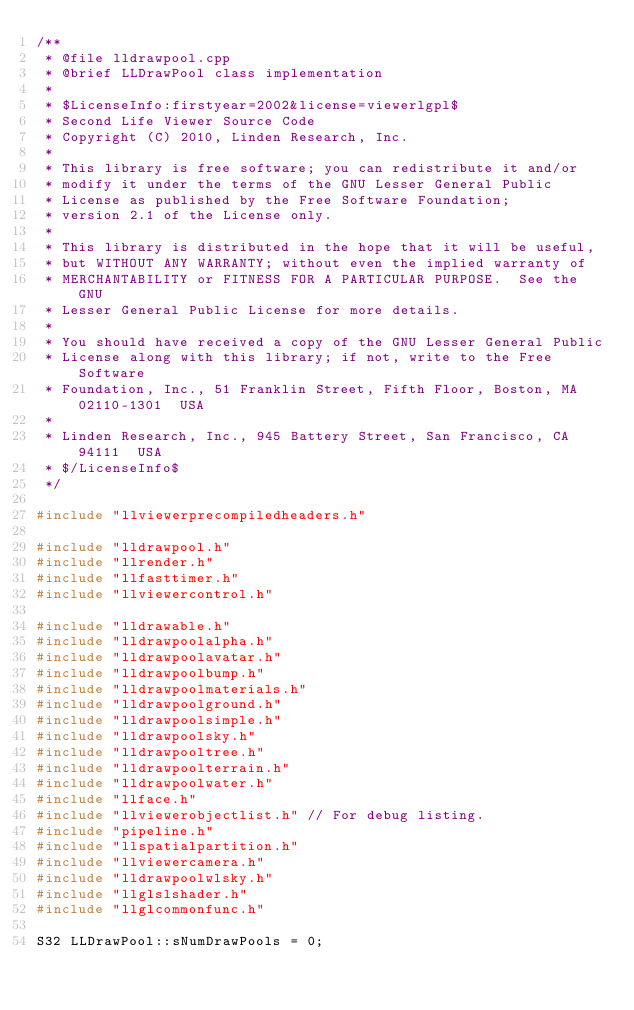Convert code to text. <code><loc_0><loc_0><loc_500><loc_500><_C++_>/** 
 * @file lldrawpool.cpp
 * @brief LLDrawPool class implementation
 *
 * $LicenseInfo:firstyear=2002&license=viewerlgpl$
 * Second Life Viewer Source Code
 * Copyright (C) 2010, Linden Research, Inc.
 * 
 * This library is free software; you can redistribute it and/or
 * modify it under the terms of the GNU Lesser General Public
 * License as published by the Free Software Foundation;
 * version 2.1 of the License only.
 * 
 * This library is distributed in the hope that it will be useful,
 * but WITHOUT ANY WARRANTY; without even the implied warranty of
 * MERCHANTABILITY or FITNESS FOR A PARTICULAR PURPOSE.  See the GNU
 * Lesser General Public License for more details.
 * 
 * You should have received a copy of the GNU Lesser General Public
 * License along with this library; if not, write to the Free Software
 * Foundation, Inc., 51 Franklin Street, Fifth Floor, Boston, MA  02110-1301  USA
 * 
 * Linden Research, Inc., 945 Battery Street, San Francisco, CA  94111  USA
 * $/LicenseInfo$
 */

#include "llviewerprecompiledheaders.h"

#include "lldrawpool.h"
#include "llrender.h"
#include "llfasttimer.h"
#include "llviewercontrol.h"

#include "lldrawable.h"
#include "lldrawpoolalpha.h"
#include "lldrawpoolavatar.h"
#include "lldrawpoolbump.h"
#include "lldrawpoolmaterials.h"
#include "lldrawpoolground.h"
#include "lldrawpoolsimple.h"
#include "lldrawpoolsky.h"
#include "lldrawpooltree.h"
#include "lldrawpoolterrain.h"
#include "lldrawpoolwater.h"
#include "llface.h"
#include "llviewerobjectlist.h" // For debug listing.
#include "pipeline.h"
#include "llspatialpartition.h"
#include "llviewercamera.h"
#include "lldrawpoolwlsky.h"
#include "llglslshader.h"
#include "llglcommonfunc.h"

S32 LLDrawPool::sNumDrawPools = 0;
</code> 